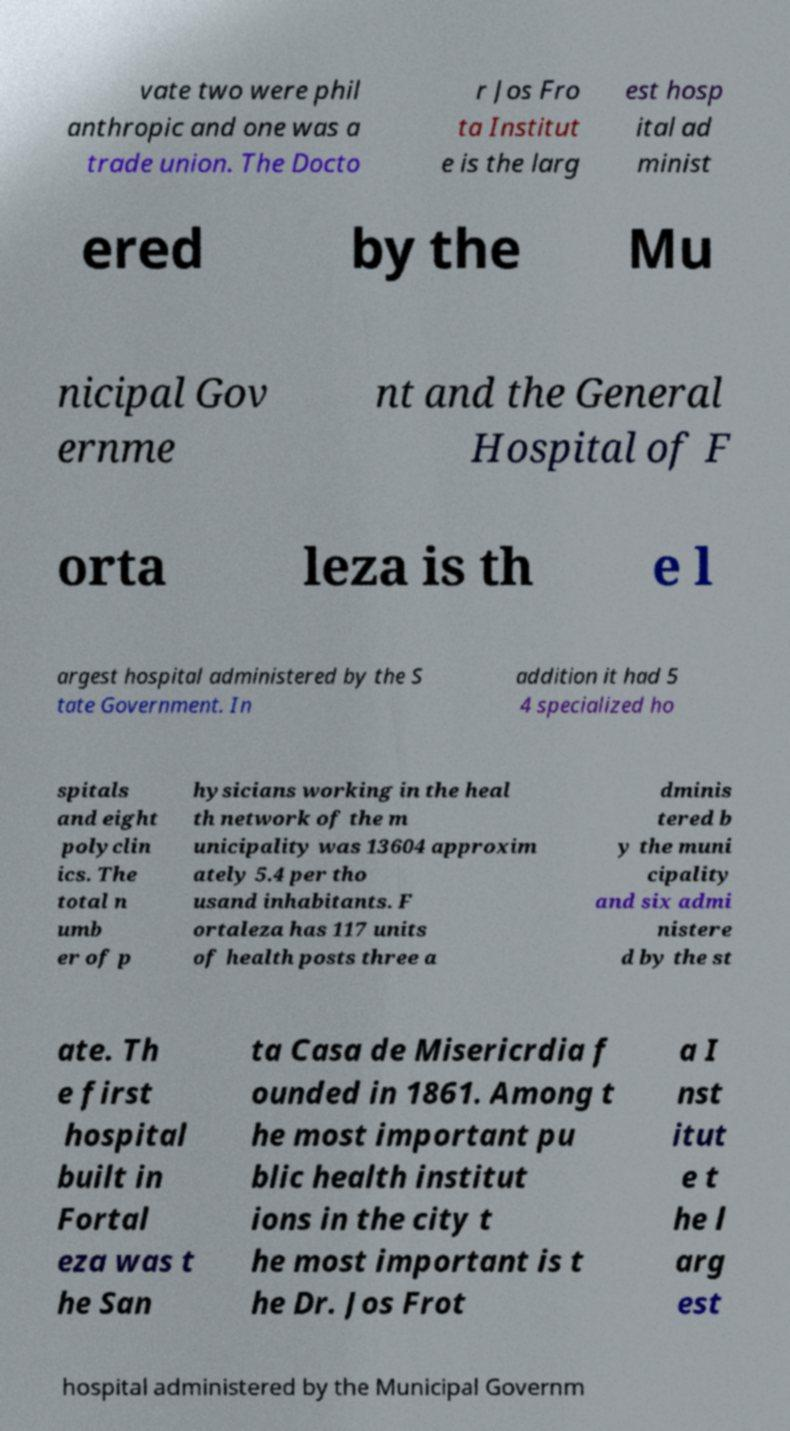What messages or text are displayed in this image? I need them in a readable, typed format. vate two were phil anthropic and one was a trade union. The Docto r Jos Fro ta Institut e is the larg est hosp ital ad minist ered by the Mu nicipal Gov ernme nt and the General Hospital of F orta leza is th e l argest hospital administered by the S tate Government. In addition it had 5 4 specialized ho spitals and eight polyclin ics. The total n umb er of p hysicians working in the heal th network of the m unicipality was 13604 approxim ately 5.4 per tho usand inhabitants. F ortaleza has 117 units of health posts three a dminis tered b y the muni cipality and six admi nistere d by the st ate. Th e first hospital built in Fortal eza was t he San ta Casa de Misericrdia f ounded in 1861. Among t he most important pu blic health institut ions in the city t he most important is t he Dr. Jos Frot a I nst itut e t he l arg est hospital administered by the Municipal Governm 